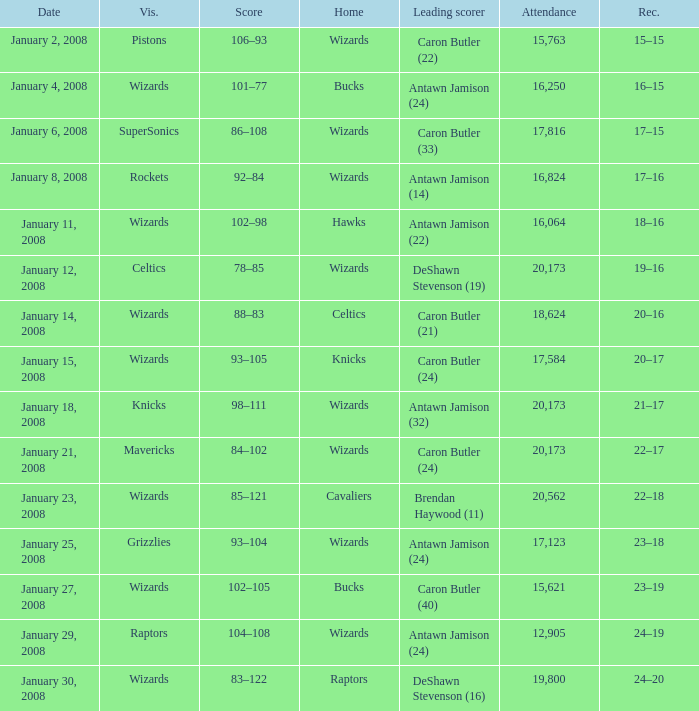What is the record when the leading scorer is Antawn Jamison (14)? 17–16. 